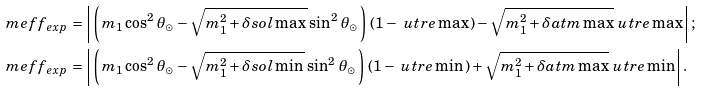Convert formula to latex. <formula><loc_0><loc_0><loc_500><loc_500>\ m e f f _ { \, e x p } \, & = \left | \, \left ( \, m _ { 1 } \cos ^ { 2 } \, \theta _ { \odot } - \sqrt { m _ { 1 } ^ { 2 } + \delta s o l \max \, } \sin ^ { 2 } \, \theta _ { \odot } \, \right ) \, ( 1 - \ u t r e \max \, ) - \sqrt { m _ { 1 } ^ { 2 } + \delta a t m \max } \ u t r e \max \, \right | ; \\ \ m e f f _ { \, e x p } \, & = \left | \, \left ( \, m _ { 1 } \cos ^ { 2 } \, \theta _ { \odot } - \sqrt { m _ { 1 } ^ { 2 } + \delta s o l \min \, } \sin ^ { 2 } \, \theta _ { \odot } \, \right ) \, ( 1 - \ u t r e \min \, ) + \sqrt { m _ { 1 } ^ { 2 } + \delta a t m \max } \ u t r e \min \, \right | .</formula> 